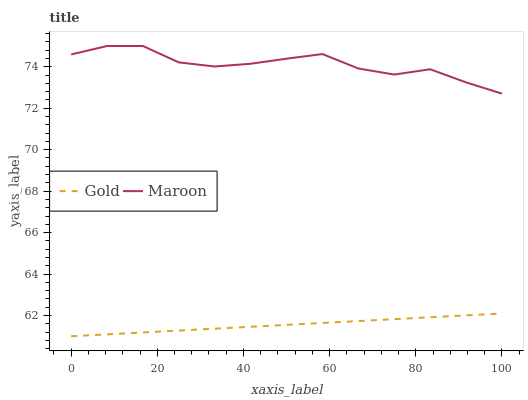Does Gold have the minimum area under the curve?
Answer yes or no. Yes. Does Maroon have the maximum area under the curve?
Answer yes or no. Yes. Does Gold have the maximum area under the curve?
Answer yes or no. No. Is Gold the smoothest?
Answer yes or no. Yes. Is Maroon the roughest?
Answer yes or no. Yes. Is Gold the roughest?
Answer yes or no. No. Does Gold have the lowest value?
Answer yes or no. Yes. Does Maroon have the highest value?
Answer yes or no. Yes. Does Gold have the highest value?
Answer yes or no. No. Is Gold less than Maroon?
Answer yes or no. Yes. Is Maroon greater than Gold?
Answer yes or no. Yes. Does Gold intersect Maroon?
Answer yes or no. No. 